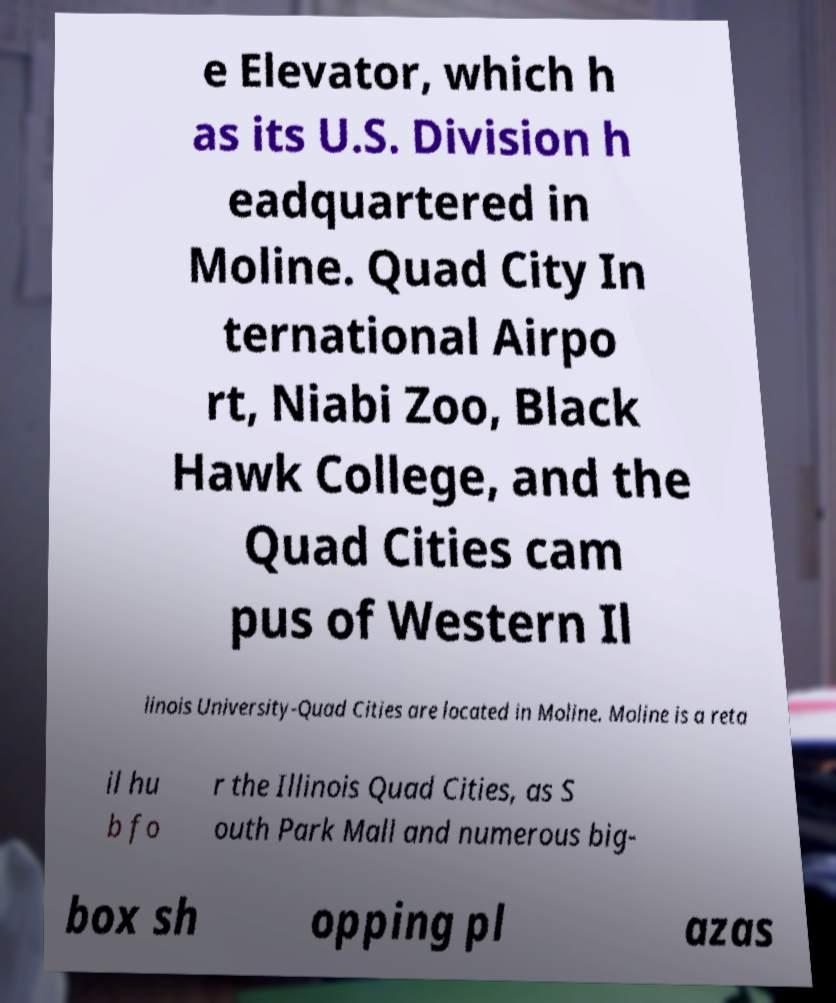Could you assist in decoding the text presented in this image and type it out clearly? e Elevator, which h as its U.S. Division h eadquartered in Moline. Quad City In ternational Airpo rt, Niabi Zoo, Black Hawk College, and the Quad Cities cam pus of Western Il linois University-Quad Cities are located in Moline. Moline is a reta il hu b fo r the Illinois Quad Cities, as S outh Park Mall and numerous big- box sh opping pl azas 